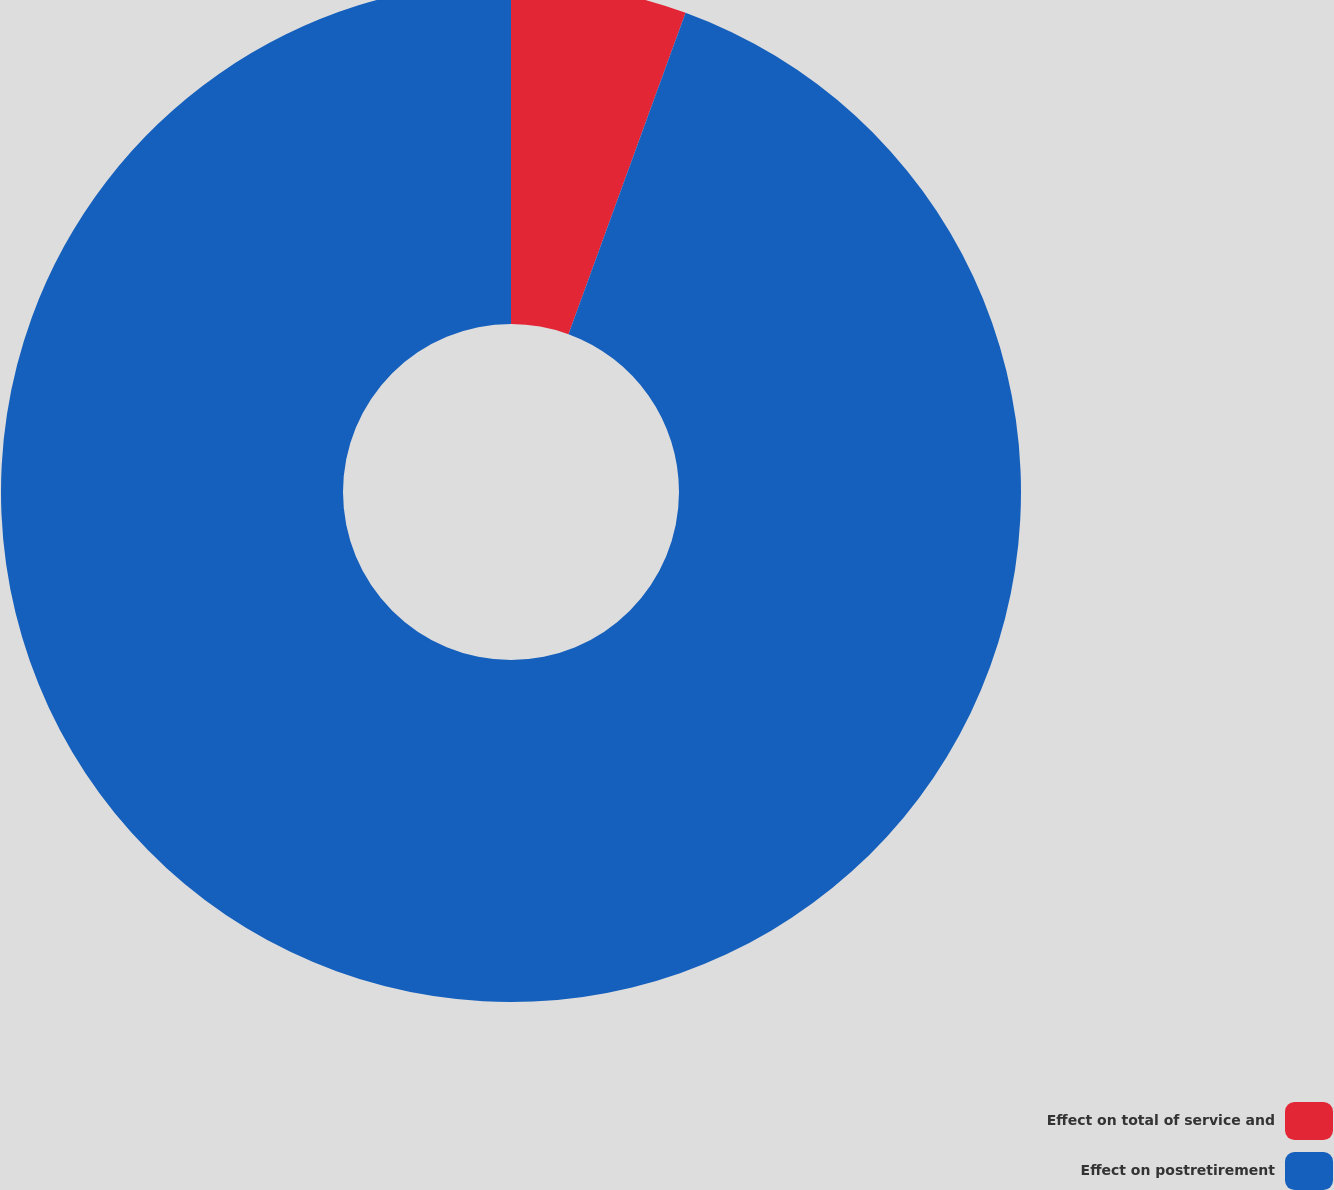Convert chart. <chart><loc_0><loc_0><loc_500><loc_500><pie_chart><fcel>Effect on total of service and<fcel>Effect on postretirement<nl><fcel>5.56%<fcel>94.44%<nl></chart> 